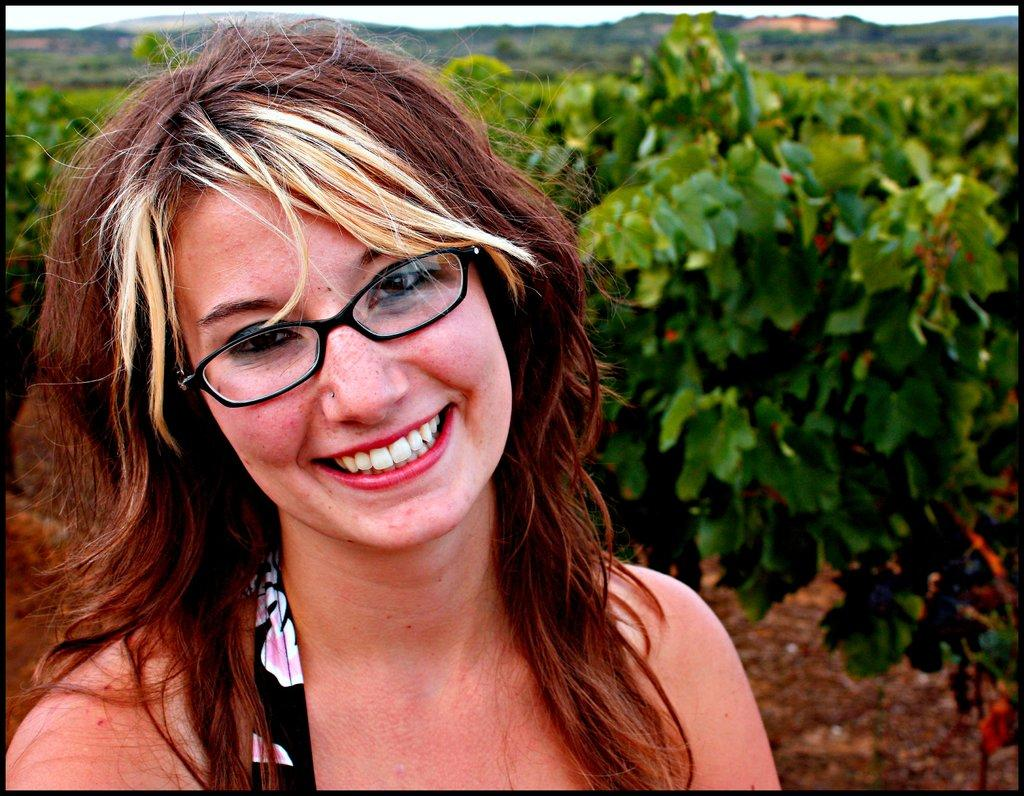Who is present in the image? There is a woman in the image. What is the woman's expression in the image? The woman is smiling in the image. What type of natural environment can be seen in the image? There are trees and hills visible in the image. What book is the woman reading in the image? There is no book present in the image, and the woman is not reading. 